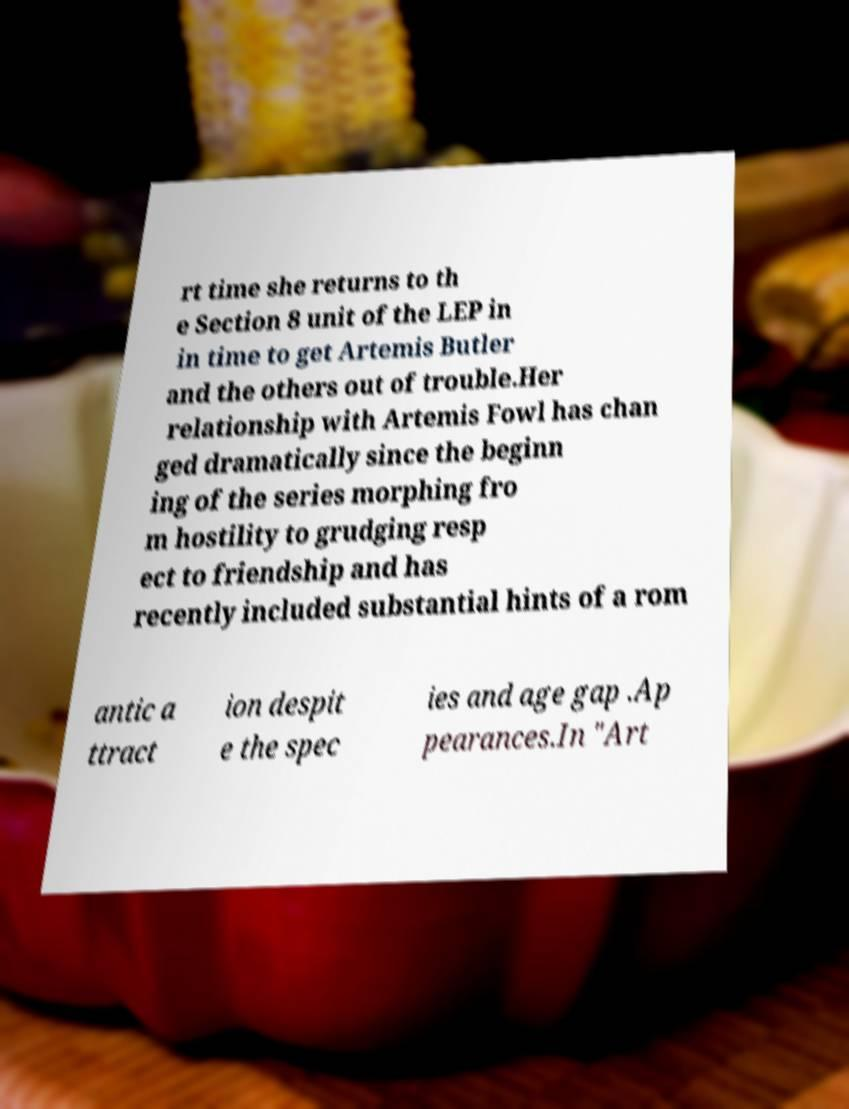Can you accurately transcribe the text from the provided image for me? rt time she returns to th e Section 8 unit of the LEP in in time to get Artemis Butler and the others out of trouble.Her relationship with Artemis Fowl has chan ged dramatically since the beginn ing of the series morphing fro m hostility to grudging resp ect to friendship and has recently included substantial hints of a rom antic a ttract ion despit e the spec ies and age gap .Ap pearances.In "Art 